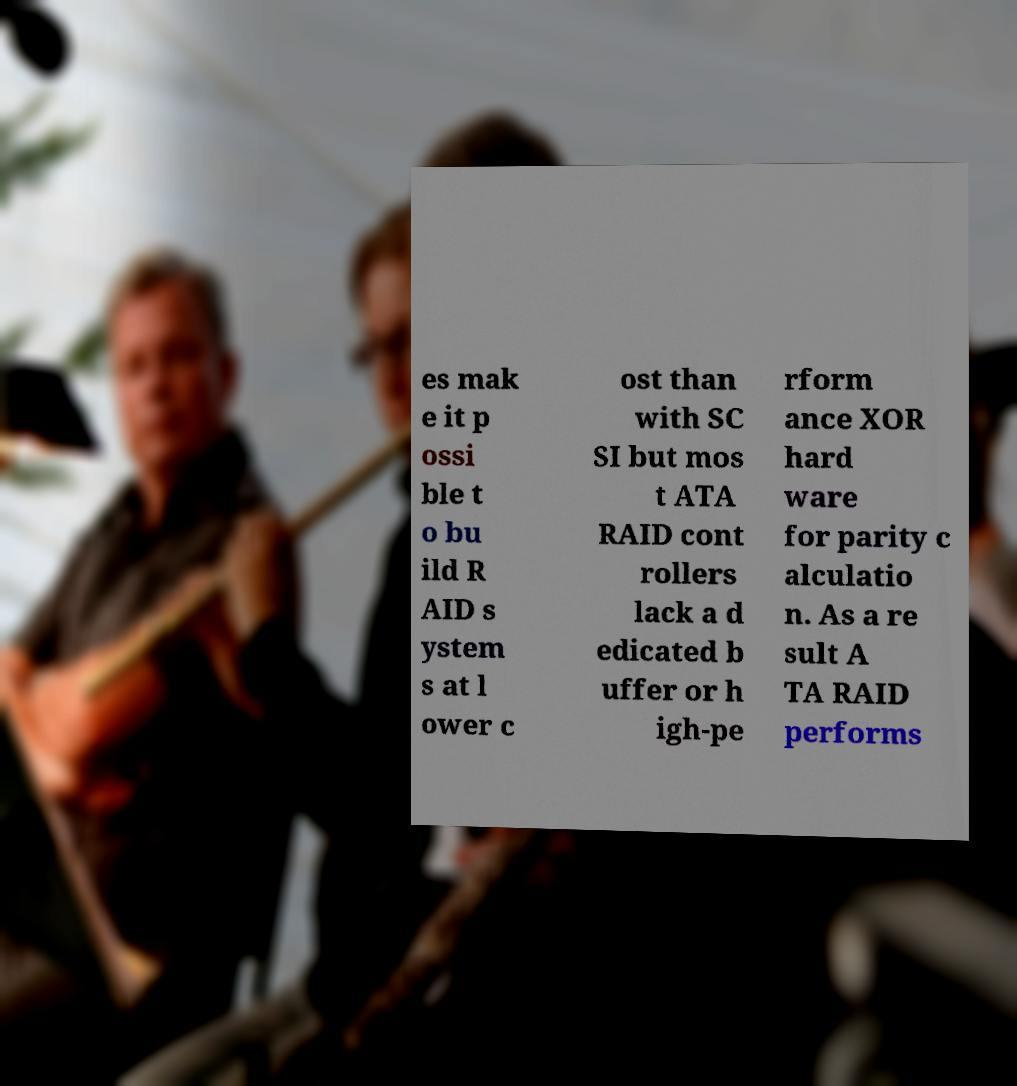There's text embedded in this image that I need extracted. Can you transcribe it verbatim? es mak e it p ossi ble t o bu ild R AID s ystem s at l ower c ost than with SC SI but mos t ATA RAID cont rollers lack a d edicated b uffer or h igh-pe rform ance XOR hard ware for parity c alculatio n. As a re sult A TA RAID performs 